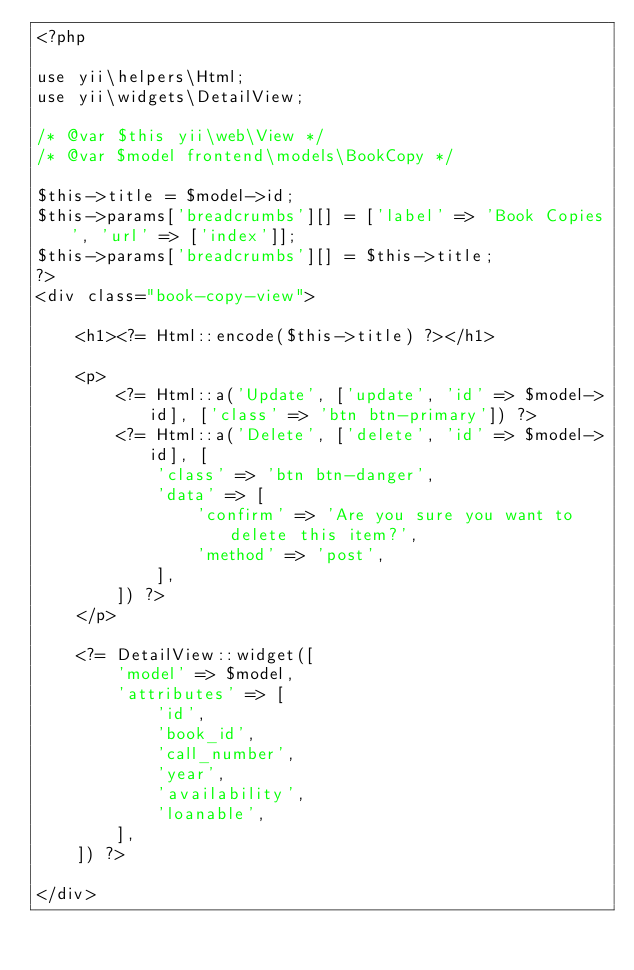<code> <loc_0><loc_0><loc_500><loc_500><_PHP_><?php

use yii\helpers\Html;
use yii\widgets\DetailView;

/* @var $this yii\web\View */
/* @var $model frontend\models\BookCopy */

$this->title = $model->id;
$this->params['breadcrumbs'][] = ['label' => 'Book Copies', 'url' => ['index']];
$this->params['breadcrumbs'][] = $this->title;
?>
<div class="book-copy-view">

    <h1><?= Html::encode($this->title) ?></h1>

    <p>
        <?= Html::a('Update', ['update', 'id' => $model->id], ['class' => 'btn btn-primary']) ?>
        <?= Html::a('Delete', ['delete', 'id' => $model->id], [
            'class' => 'btn btn-danger',
            'data' => [
                'confirm' => 'Are you sure you want to delete this item?',
                'method' => 'post',
            ],
        ]) ?>
    </p>

    <?= DetailView::widget([
        'model' => $model,
        'attributes' => [
            'id',
            'book_id',
            'call_number',
            'year',
            'availability',
            'loanable',
        ],
    ]) ?>

</div>
</code> 